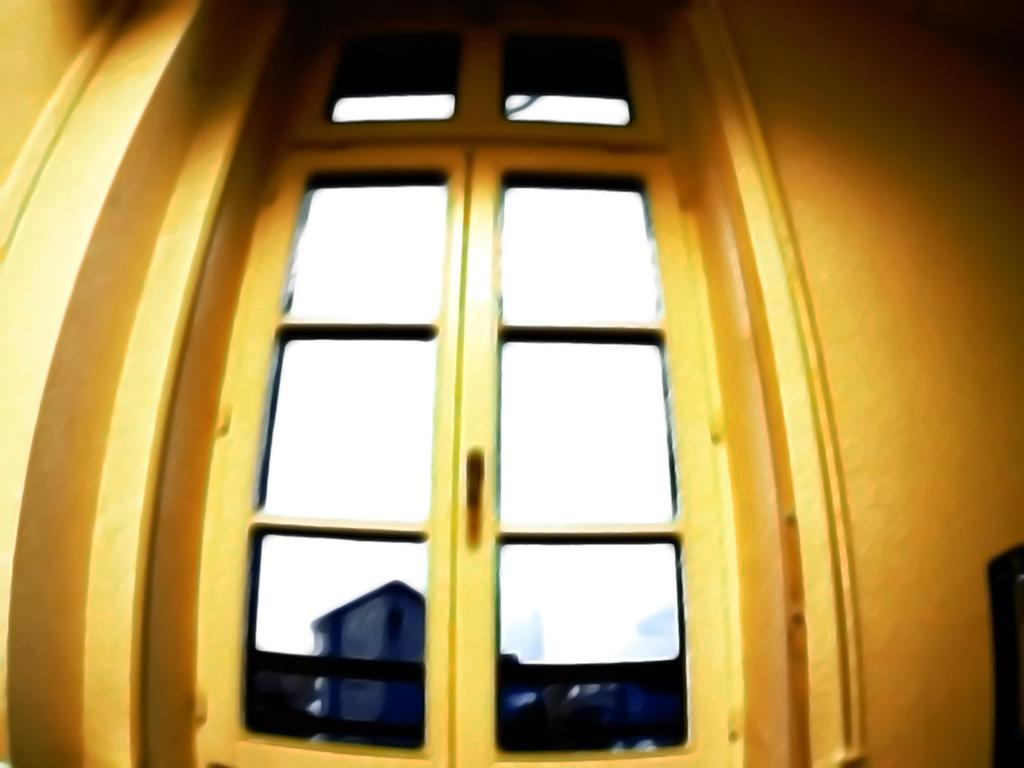What is present in the image that serves as an entryway? There is a door in the image. What feature does the door have? The door has glass. What can be seen through the glass on the door? There are objects visible through the glass. How do the fairies adjust the door's handle in the image? There are no fairies present in the image, and therefore no adjustments to the door's handle can be observed. What type of teeth can be seen on the door's frame in the image? There are no teeth visible on the door's frame in the image. 